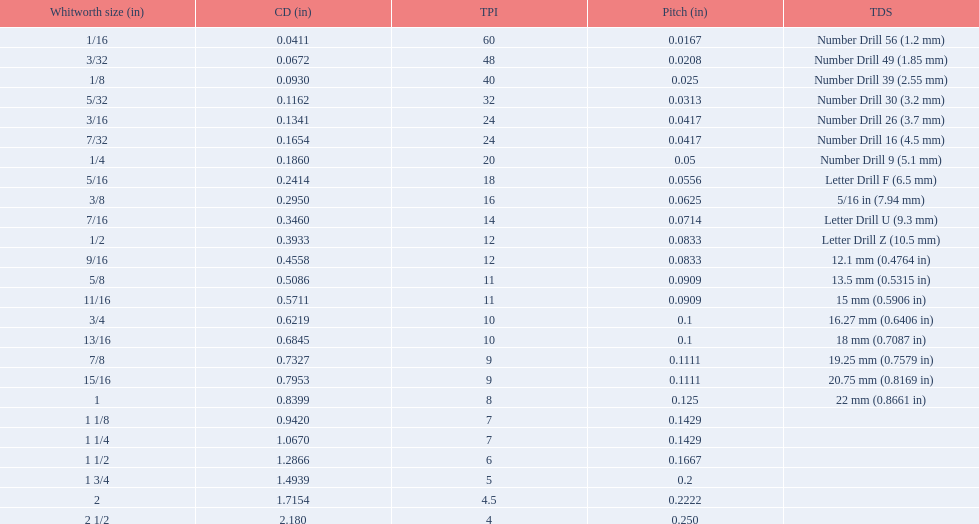What is the least core diameter (in)? 0.0411. 